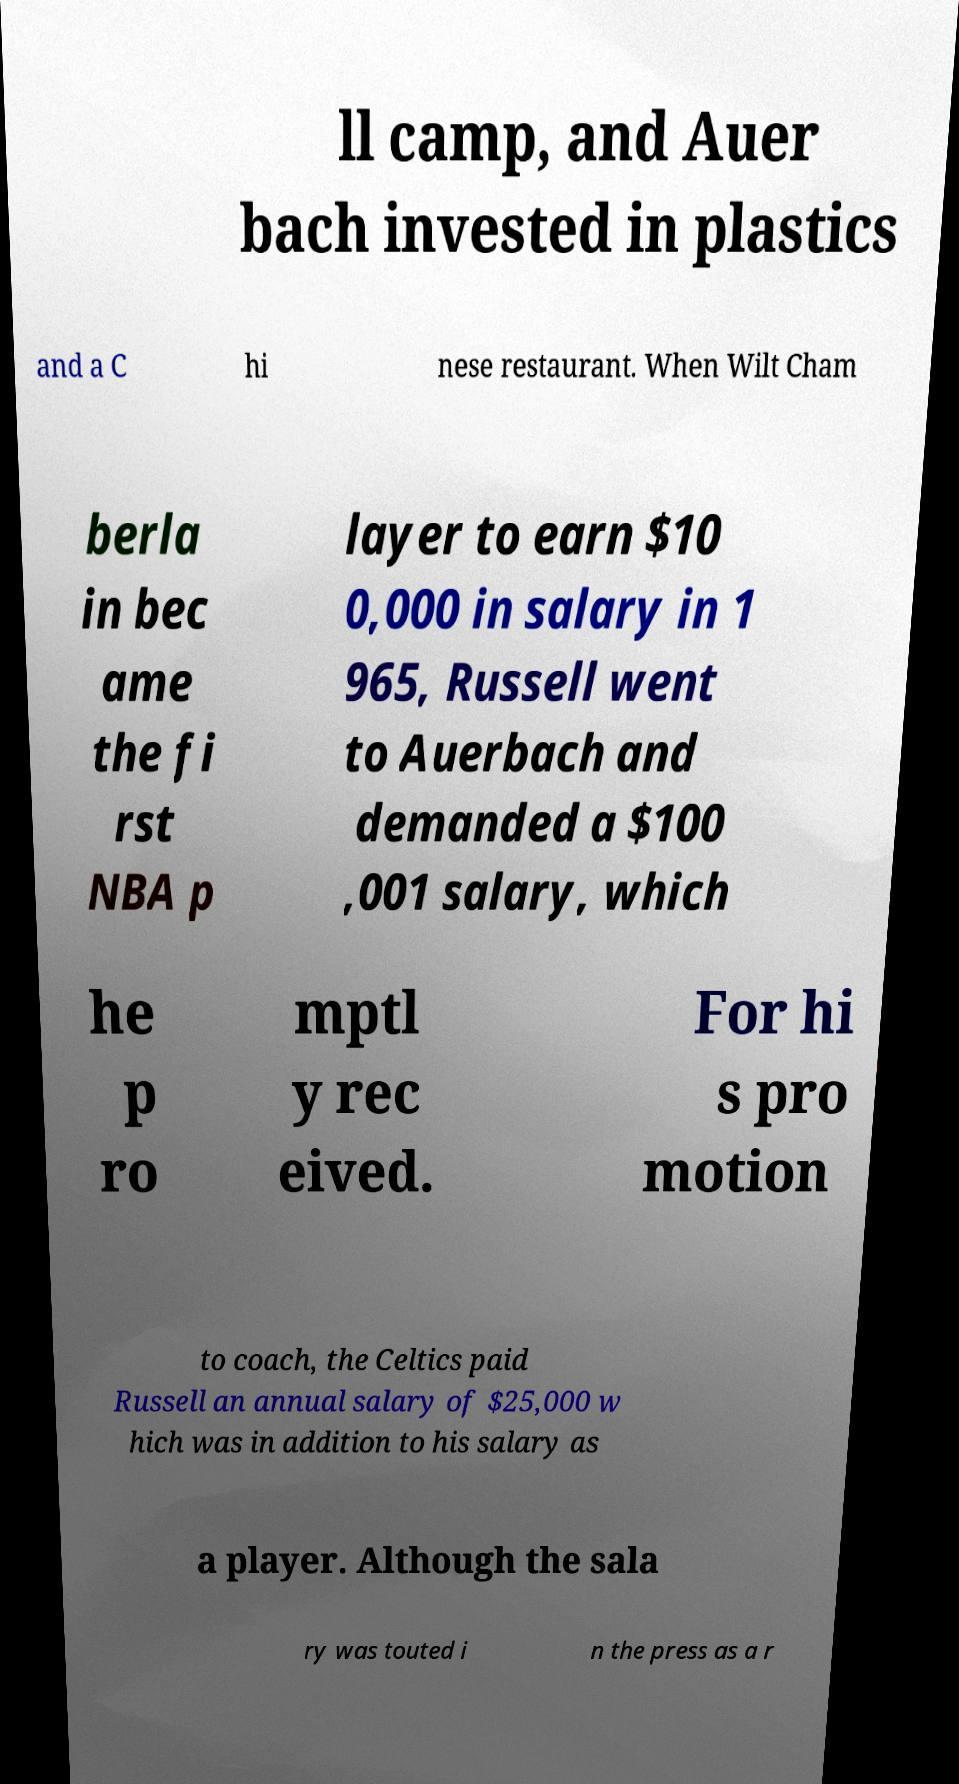Please identify and transcribe the text found in this image. ll camp, and Auer bach invested in plastics and a C hi nese restaurant. When Wilt Cham berla in bec ame the fi rst NBA p layer to earn $10 0,000 in salary in 1 965, Russell went to Auerbach and demanded a $100 ,001 salary, which he p ro mptl y rec eived. For hi s pro motion to coach, the Celtics paid Russell an annual salary of $25,000 w hich was in addition to his salary as a player. Although the sala ry was touted i n the press as a r 